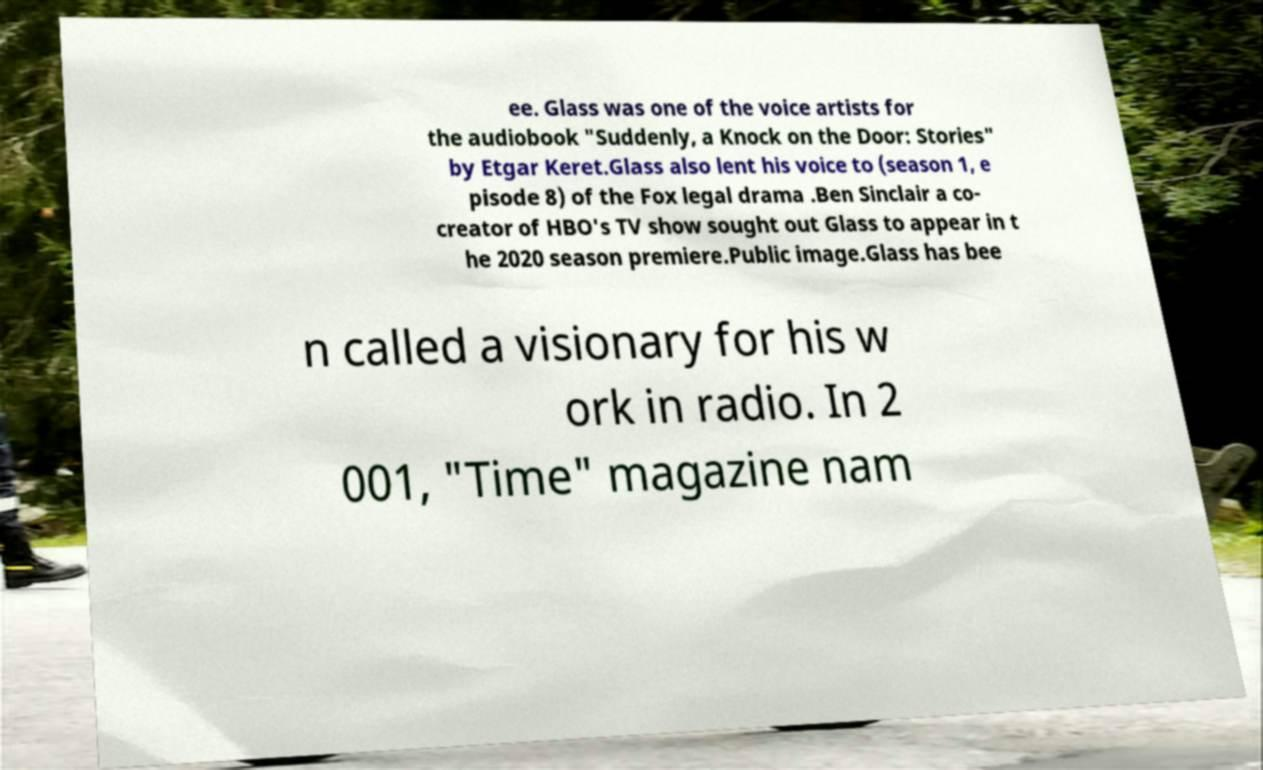Could you assist in decoding the text presented in this image and type it out clearly? ee. Glass was one of the voice artists for the audiobook "Suddenly, a Knock on the Door: Stories" by Etgar Keret.Glass also lent his voice to (season 1, e pisode 8) of the Fox legal drama .Ben Sinclair a co- creator of HBO's TV show sought out Glass to appear in t he 2020 season premiere.Public image.Glass has bee n called a visionary for his w ork in radio. In 2 001, "Time" magazine nam 